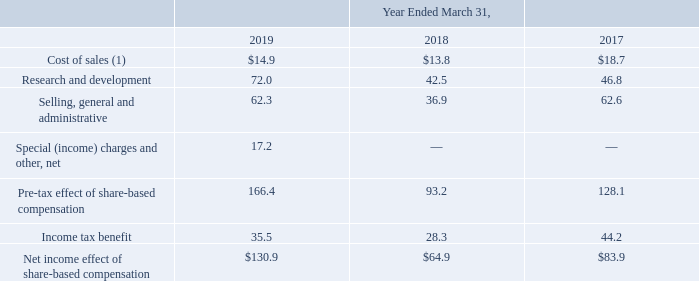Note 16. Share-Based Compensation
Share-Based Compensation Expense
The following table presents the details of the Company's share-based compensation expense (in millions):
(1) During the year ended March 31, 2019, $17.2 million of share-based compensation expense was capitalized to inventory, and $14.9 million of previously capitalized share-based compensation expense in inventory was sold. During the year ended March 31, 2018, $11.9 million of share-based compensation expense was capitalized to inventory and $13.8 million of previously capitalized share-based compensation expense in inventory that was sold. During the year ended March 31, 2017, $11.3 million of share-based compensation expense was capitalized to inventory. The amount of sharebased compensation included in cost of sales during fiscal 2017 included $14.5 million of previously capitalized sharebased compensation expense in inventory was sold and $4.2 million of share-based compensation expense related to the Company's acquisition of Atmel that was not previously capitalized into inventory.
The amount of unearned share-based compensation currently estimated to be expensed in the remainder of fiscal 2020 through fiscal 2024 related to unvested share-based payment awards at March 31, 2019 is $253.4 million. The weighted average period over which the unearned share-based compensation is expected to be recognized is approximately 1.88 years.
Which years does the table provide information for the details of the Company's share-based compensation expense? 2019, 2018, 2017. What was the weighted average period over which the unearned share-based compensation is expected to be recognized? Approximately 1.88 years. What was the cost of sales in 2017?
Answer scale should be: million. 18.7. What was the change in the cost of sales between 2017 and 2018?
Answer scale should be: million. 13.8-18.7
Answer: -4.9. How many years did research and development expenses exceed $50 million? 2019
Answer: 1. What was the percentage change in the Income tax benefit between 2018 and 2019?
Answer scale should be: percent. (35.5-28.3)/28.3
Answer: 25.44. 